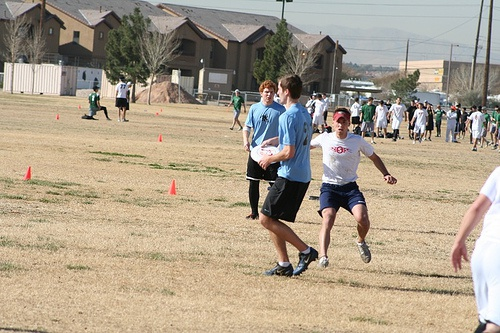Describe the objects in this image and their specific colors. I can see people in gray, black, and maroon tones, people in gray, darkgray, black, white, and maroon tones, people in gray, white, brown, tan, and darkgray tones, people in gray, black, lightblue, and white tones, and frisbee in gray, white, lightpink, brown, and tan tones in this image. 